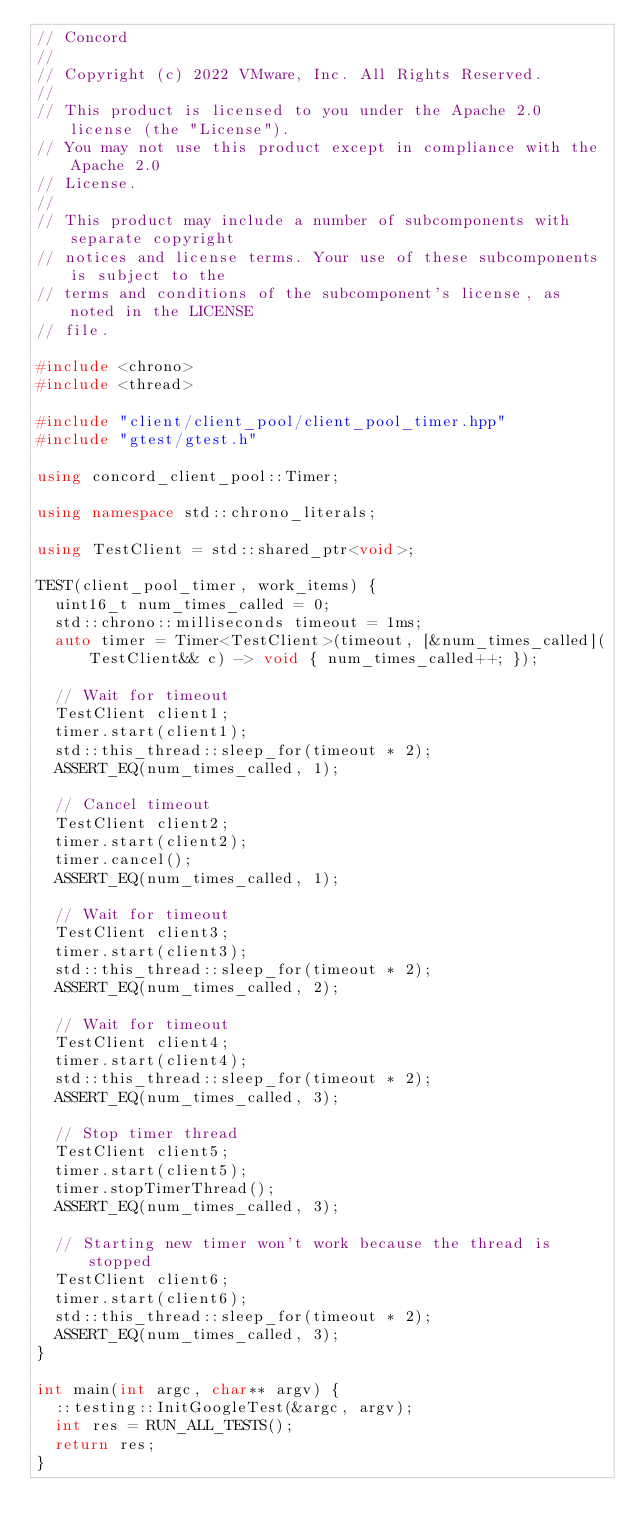Convert code to text. <code><loc_0><loc_0><loc_500><loc_500><_C++_>// Concord
//
// Copyright (c) 2022 VMware, Inc. All Rights Reserved.
//
// This product is licensed to you under the Apache 2.0 license (the "License").
// You may not use this product except in compliance with the Apache 2.0
// License.
//
// This product may include a number of subcomponents with separate copyright
// notices and license terms. Your use of these subcomponents is subject to the
// terms and conditions of the subcomponent's license, as noted in the LICENSE
// file.

#include <chrono>
#include <thread>

#include "client/client_pool/client_pool_timer.hpp"
#include "gtest/gtest.h"

using concord_client_pool::Timer;

using namespace std::chrono_literals;

using TestClient = std::shared_ptr<void>;

TEST(client_pool_timer, work_items) {
  uint16_t num_times_called = 0;
  std::chrono::milliseconds timeout = 1ms;
  auto timer = Timer<TestClient>(timeout, [&num_times_called](TestClient&& c) -> void { num_times_called++; });

  // Wait for timeout
  TestClient client1;
  timer.start(client1);
  std::this_thread::sleep_for(timeout * 2);
  ASSERT_EQ(num_times_called, 1);

  // Cancel timeout
  TestClient client2;
  timer.start(client2);
  timer.cancel();
  ASSERT_EQ(num_times_called, 1);

  // Wait for timeout
  TestClient client3;
  timer.start(client3);
  std::this_thread::sleep_for(timeout * 2);
  ASSERT_EQ(num_times_called, 2);

  // Wait for timeout
  TestClient client4;
  timer.start(client4);
  std::this_thread::sleep_for(timeout * 2);
  ASSERT_EQ(num_times_called, 3);

  // Stop timer thread
  TestClient client5;
  timer.start(client5);
  timer.stopTimerThread();
  ASSERT_EQ(num_times_called, 3);

  // Starting new timer won't work because the thread is stopped
  TestClient client6;
  timer.start(client6);
  std::this_thread::sleep_for(timeout * 2);
  ASSERT_EQ(num_times_called, 3);
}

int main(int argc, char** argv) {
  ::testing::InitGoogleTest(&argc, argv);
  int res = RUN_ALL_TESTS();
  return res;
}
</code> 